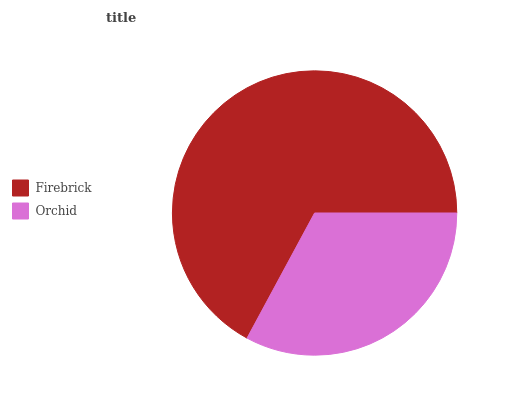Is Orchid the minimum?
Answer yes or no. Yes. Is Firebrick the maximum?
Answer yes or no. Yes. Is Orchid the maximum?
Answer yes or no. No. Is Firebrick greater than Orchid?
Answer yes or no. Yes. Is Orchid less than Firebrick?
Answer yes or no. Yes. Is Orchid greater than Firebrick?
Answer yes or no. No. Is Firebrick less than Orchid?
Answer yes or no. No. Is Firebrick the high median?
Answer yes or no. Yes. Is Orchid the low median?
Answer yes or no. Yes. Is Orchid the high median?
Answer yes or no. No. Is Firebrick the low median?
Answer yes or no. No. 